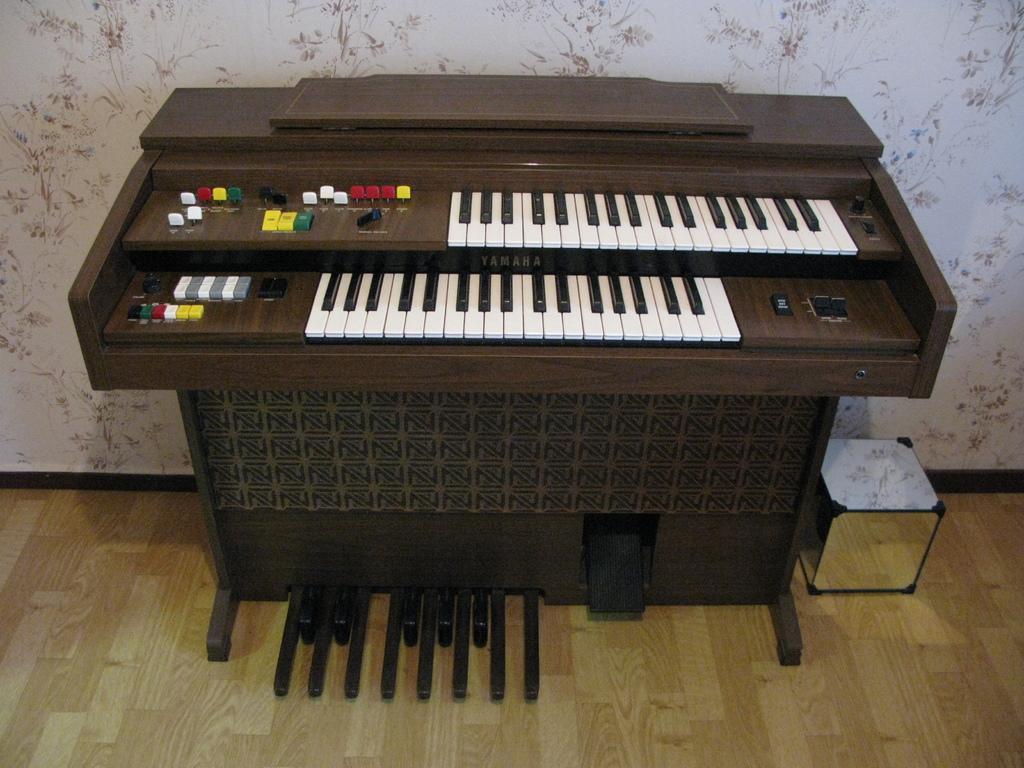Describe this image in one or two sentences. This image is having a piano. Beside there is a box. Background there is a wall. Bottom there is a wooden floor. 